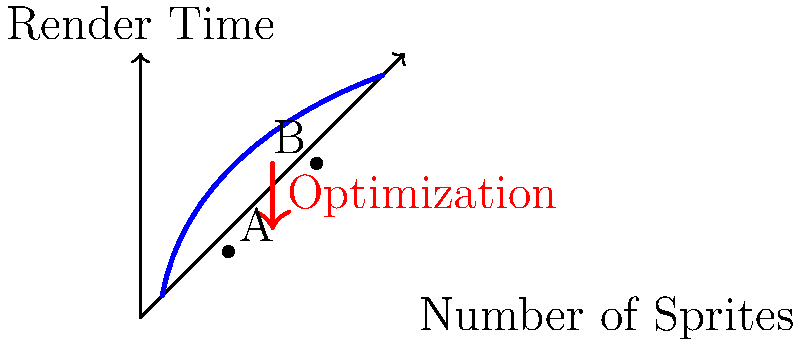In a Lua-based game engine, you're tasked with optimizing the rendering of multiple sprites with varying transparency levels. The graph shows the relationship between the number of sprites and render time. Point A represents the current performance, while point B represents the desired performance after optimization. Which of the following techniques would be most effective in achieving this optimization?

a) Implementing sprite batching
b) Using hardware-accelerated alpha blending
c) Reducing sprite resolution
d) Increasing GPU clock speed To optimize the rendering of multiple sprites with different transparency levels, we need to consider several factors:

1. Current situation (Point A):
   - Relatively few sprites
   - High render time

2. Desired situation (Point B):
   - More sprites
   - Lower render time relative to the number of sprites

3. Transparency consideration:
   - Dealing with varying transparency levels

Step-by-step analysis:

1. Sprite batching (option a):
   - Combines multiple sprites into a single draw call
   - Reduces CPU overhead
   - Efficiently handles multiple sprites
   - Can work well with different transparency levels

2. Hardware-accelerated alpha blending (option b):
   - Utilizes GPU for transparency calculations
   - Improves performance for transparent sprites
   - Doesn't necessarily reduce draw calls

3. Reducing sprite resolution (option c):
   - May slightly improve performance
   - Negatively impacts visual quality
   - Doesn't address the core issue of multiple draw calls

4. Increasing GPU clock speed (option d):
   - Hardware solution, not a programming optimization
   - May provide marginal improvements
   - Doesn't address the specific challenge of multiple sprites

Conclusion:
Implementing sprite batching (option a) is the most effective technique. It directly addresses the issue of rendering multiple sprites by reducing draw calls, which is crucial for optimizing performance when dealing with a large number of sprites. It also works well with varying transparency levels, making it the best choice for the given scenario.
Answer: Implementing sprite batching 